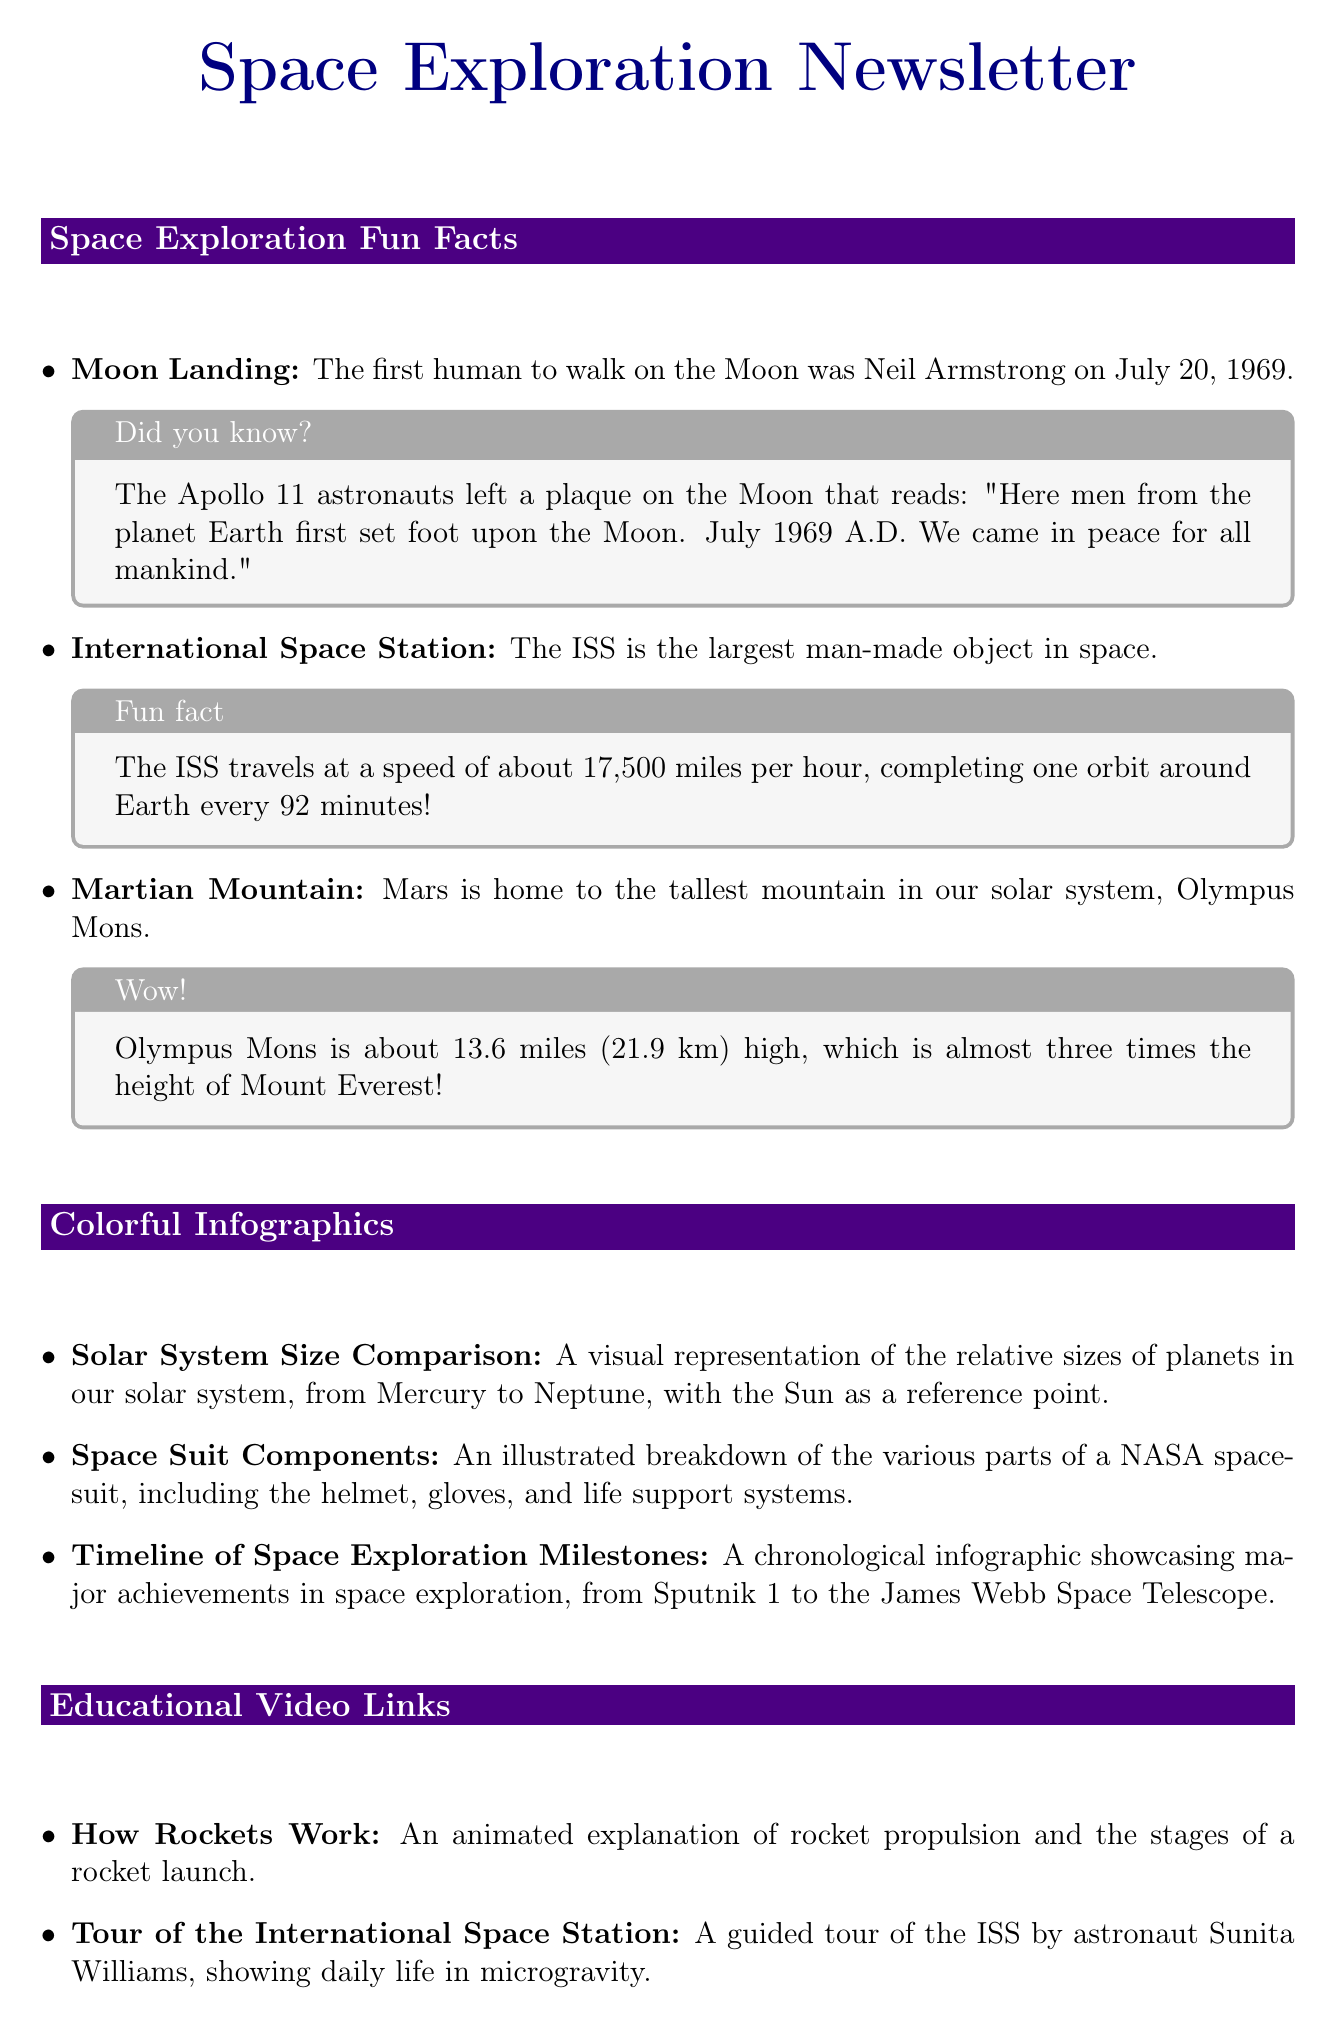What is the date of the first Moon landing? The document states that the first human to walk on the Moon was Neil Armstrong on July 20, 1969.
Answer: July 20, 1969 What is the speed of the International Space Station? According to the newsletter, the ISS travels at a speed of about 17,500 miles per hour.
Answer: 17,500 miles per hour Which mountain is the tallest in our solar system? The document mentions that Mars is home to Olympus Mons, the tallest mountain in our solar system.
Answer: Olympus Mons What is the name of NASA's Mars rover that landed in 2021? The Interactive Quiz section poses the question with the correct answer being Perseverance.
Answer: Perseverance How many infographics are included in the newsletter? The Colorful Infographics section lists three different infographics, which can be counted.
Answer: Three Which planet in our solar system has the most moons? The newsletter states that Saturn has the most moons among the given options.
Answer: Saturn What is one of the careers mentioned related to space exploration? The document provides a brief overview mentioning several careers, one of which is astronauts.
Answer: Astronauts What is the title of the video explaining how rockets work? The Educational Video Links section lists a video titled "How Rockets Work."
Answer: How Rockets Work 